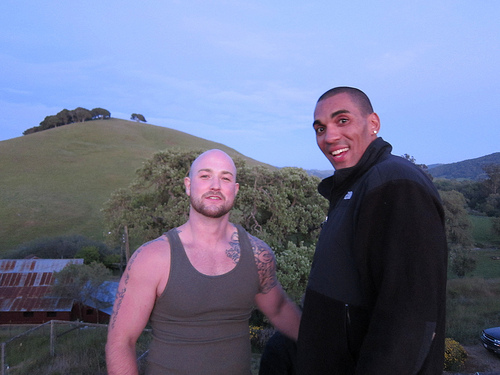<image>
Is the beard on the man? Yes. Looking at the image, I can see the beard is positioned on top of the man, with the man providing support. Where is the man in relation to the tree? Is it behind the tree? No. The man is not behind the tree. From this viewpoint, the man appears to be positioned elsewhere in the scene. 